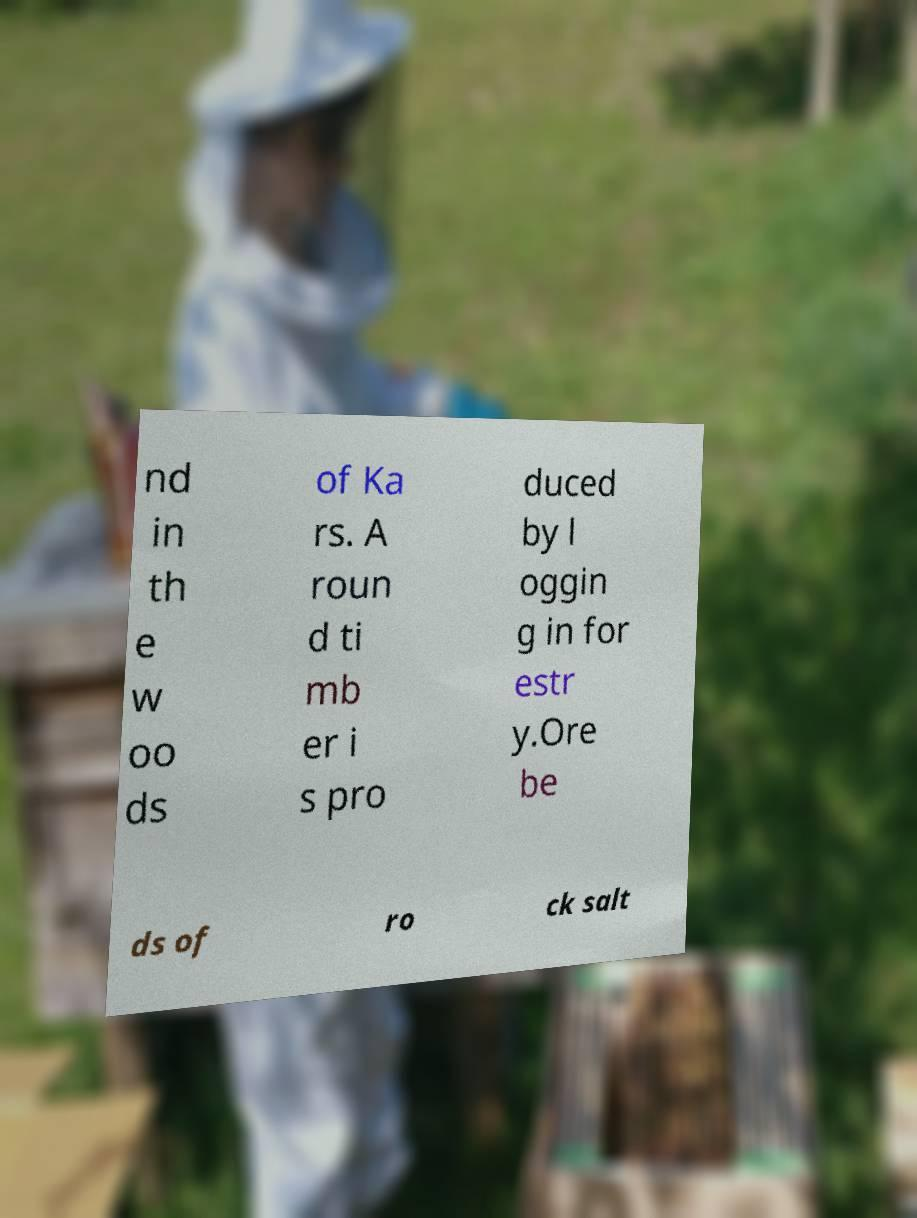I need the written content from this picture converted into text. Can you do that? nd in th e w oo ds of Ka rs. A roun d ti mb er i s pro duced by l oggin g in for estr y.Ore be ds of ro ck salt 